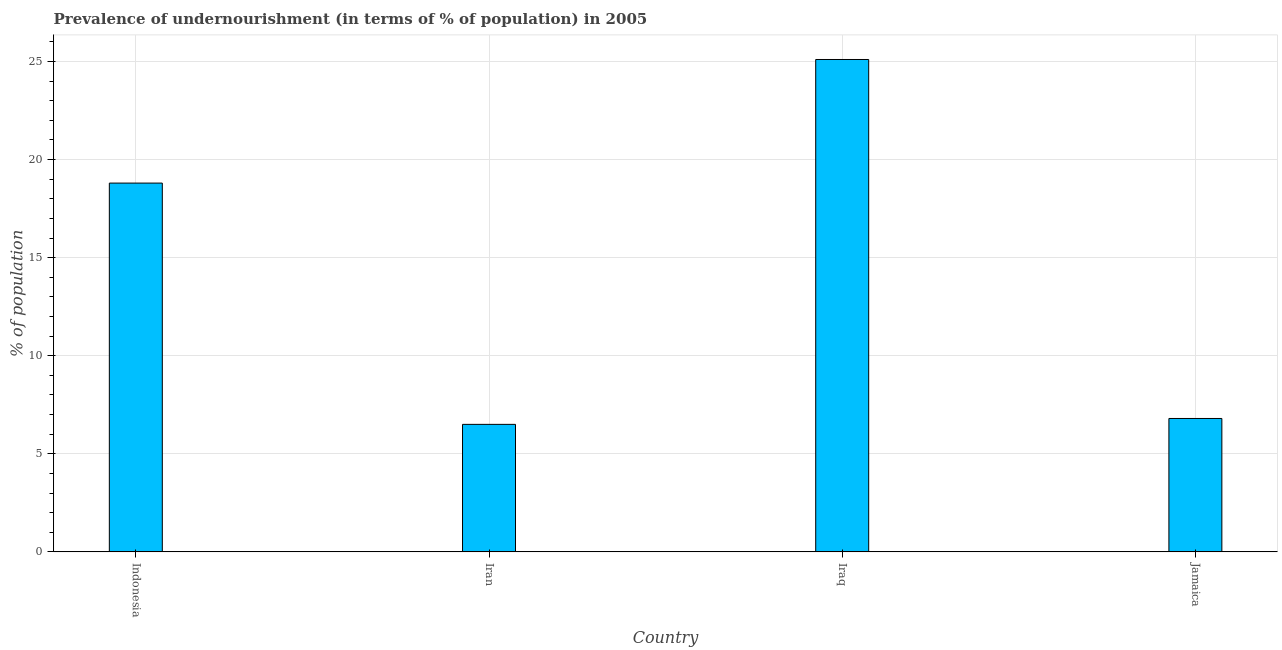Does the graph contain any zero values?
Your answer should be very brief. No. Does the graph contain grids?
Your answer should be very brief. Yes. What is the title of the graph?
Offer a terse response. Prevalence of undernourishment (in terms of % of population) in 2005. What is the label or title of the X-axis?
Make the answer very short. Country. What is the label or title of the Y-axis?
Ensure brevity in your answer.  % of population. Across all countries, what is the maximum percentage of undernourished population?
Offer a terse response. 25.1. In which country was the percentage of undernourished population maximum?
Ensure brevity in your answer.  Iraq. In which country was the percentage of undernourished population minimum?
Provide a short and direct response. Iran. What is the sum of the percentage of undernourished population?
Offer a very short reply. 57.2. What is the average percentage of undernourished population per country?
Make the answer very short. 14.3. What is the ratio of the percentage of undernourished population in Indonesia to that in Iraq?
Provide a succinct answer. 0.75. Is the percentage of undernourished population in Indonesia less than that in Jamaica?
Give a very brief answer. No. Is the sum of the percentage of undernourished population in Indonesia and Iraq greater than the maximum percentage of undernourished population across all countries?
Your response must be concise. Yes. What is the difference between the highest and the lowest percentage of undernourished population?
Your answer should be very brief. 18.6. How many bars are there?
Offer a terse response. 4. How many countries are there in the graph?
Your answer should be very brief. 4. What is the difference between two consecutive major ticks on the Y-axis?
Make the answer very short. 5. What is the % of population of Iran?
Provide a short and direct response. 6.5. What is the % of population in Iraq?
Ensure brevity in your answer.  25.1. What is the difference between the % of population in Indonesia and Iran?
Your answer should be compact. 12.3. What is the difference between the % of population in Iran and Iraq?
Your answer should be compact. -18.6. What is the difference between the % of population in Iraq and Jamaica?
Give a very brief answer. 18.3. What is the ratio of the % of population in Indonesia to that in Iran?
Offer a terse response. 2.89. What is the ratio of the % of population in Indonesia to that in Iraq?
Keep it short and to the point. 0.75. What is the ratio of the % of population in Indonesia to that in Jamaica?
Your answer should be compact. 2.77. What is the ratio of the % of population in Iran to that in Iraq?
Offer a very short reply. 0.26. What is the ratio of the % of population in Iran to that in Jamaica?
Ensure brevity in your answer.  0.96. What is the ratio of the % of population in Iraq to that in Jamaica?
Give a very brief answer. 3.69. 